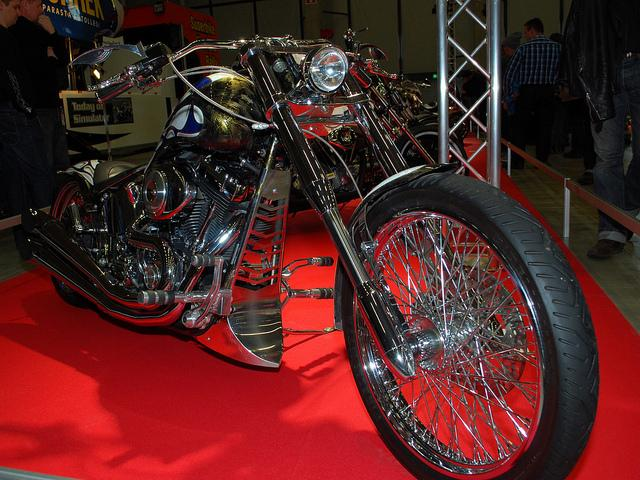Where is this bike located? museum 